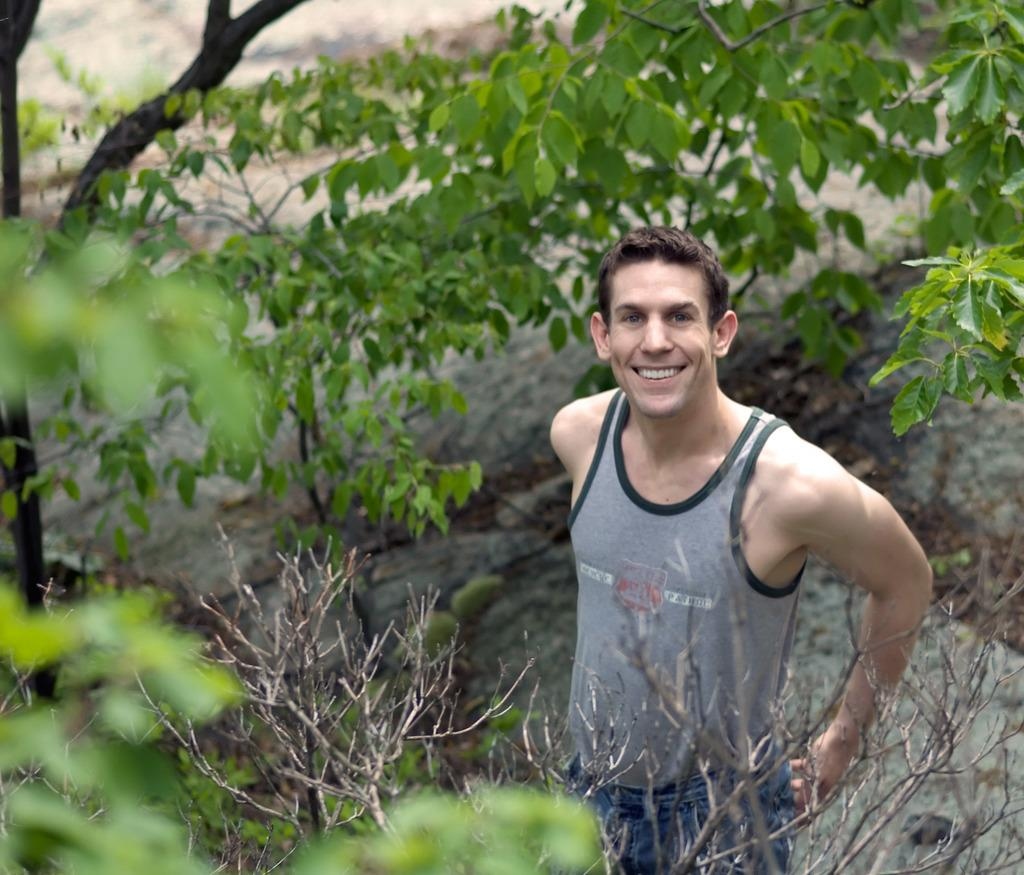What is the person in the image doing? The person is standing in the image. What is the person's facial expression? The person is smiling. What can be seen in the background of the image? There are trees around the person. What song is the person singing in the image? There is no indication in the image that the person is singing, so it cannot be determined from the picture. 